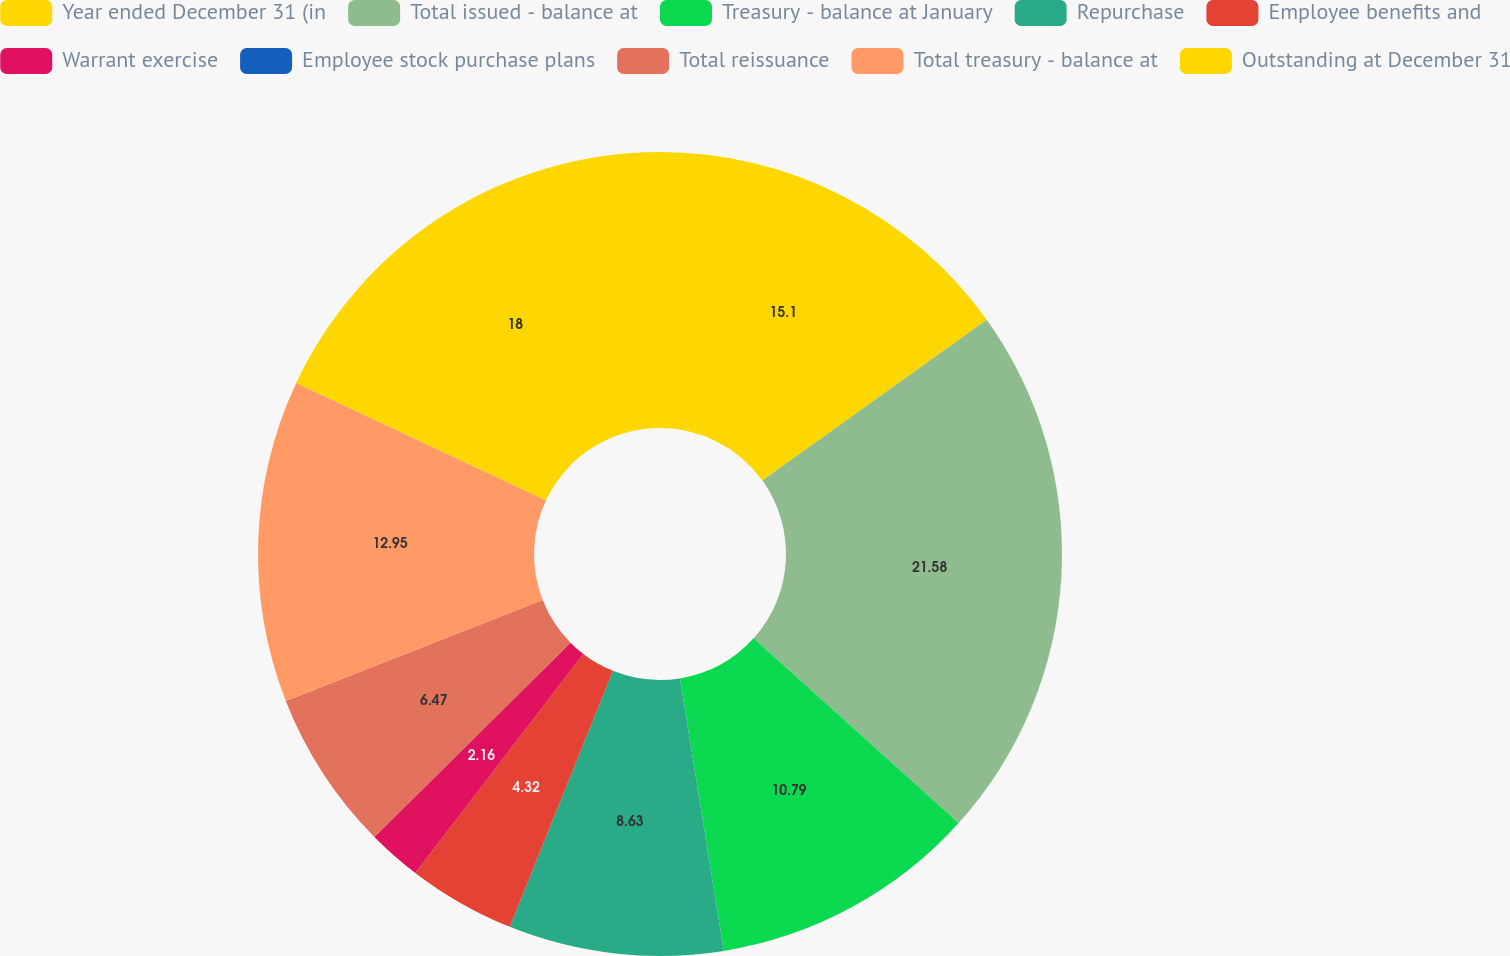<chart> <loc_0><loc_0><loc_500><loc_500><pie_chart><fcel>Year ended December 31 (in<fcel>Total issued - balance at<fcel>Treasury - balance at January<fcel>Repurchase<fcel>Employee benefits and<fcel>Warrant exercise<fcel>Employee stock purchase plans<fcel>Total reissuance<fcel>Total treasury - balance at<fcel>Outstanding at December 31<nl><fcel>15.1%<fcel>21.57%<fcel>10.79%<fcel>8.63%<fcel>4.32%<fcel>2.16%<fcel>0.0%<fcel>6.47%<fcel>12.95%<fcel>18.0%<nl></chart> 